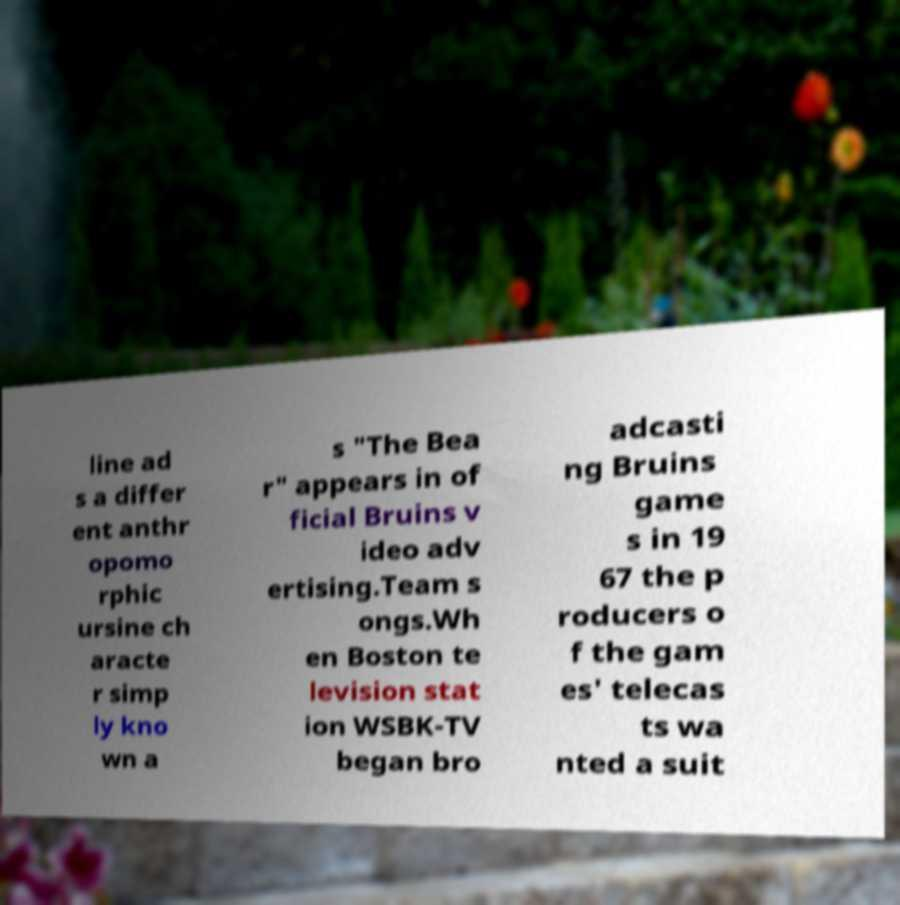Could you assist in decoding the text presented in this image and type it out clearly? line ad s a differ ent anthr opomo rphic ursine ch aracte r simp ly kno wn a s "The Bea r" appears in of ficial Bruins v ideo adv ertising.Team s ongs.Wh en Boston te levision stat ion WSBK-TV began bro adcasti ng Bruins game s in 19 67 the p roducers o f the gam es' telecas ts wa nted a suit 